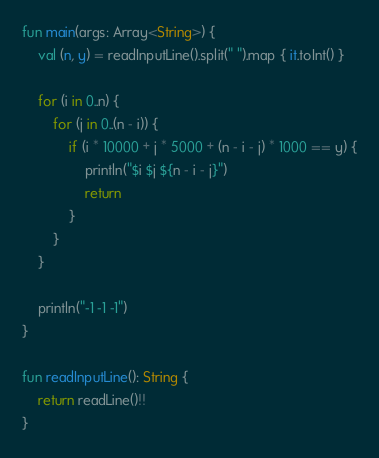Convert code to text. <code><loc_0><loc_0><loc_500><loc_500><_Kotlin_>fun main(args: Array<String>) {
    val (n, y) = readInputLine().split(" ").map { it.toInt() }
    
    for (i in 0..n) {
        for (j in 0..(n - i)) {
            if (i * 10000 + j * 5000 + (n - i - j) * 1000 == y) {
                println("$i $j ${n - i - j}")
                return
            }
        }
    }
    
    println("-1 -1 -1")
}
 
fun readInputLine(): String {
    return readLine()!!
}
</code> 